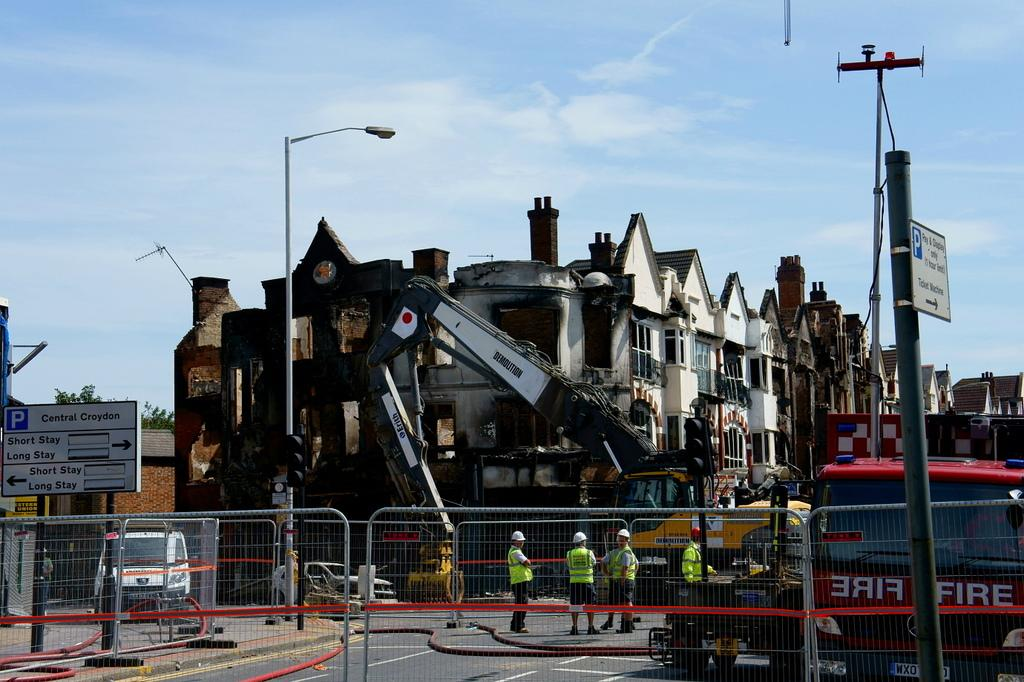What type of structures can be seen in the image? There are buildings with windows in the image. What utility infrastructure is visible in the image? Electrical poles are visible in the image. What type of transportation is present in the image? Vehicles are present in the image. Are there any people in the image? Yes, people are in the image. What type of barrier is present in the image? There is a fence in the image. What type of signage is visible in the image? Boards are visible in the image. What type of construction equipment is present in the image? A crane is present in the image. What type of vertical structure is visible in the image? There is a pole in the image. What can be seen in the background of the image? The sky is visible in the background of the image. What type of note is being passed between the zebras in the image? There are no zebras present in the image, so there is no note being passed between them. What type of hairstyle is being worn by the people in the image? The provided facts do not mention any details about the people's hairstyles, so we cannot determine their hairstyles from the image. 